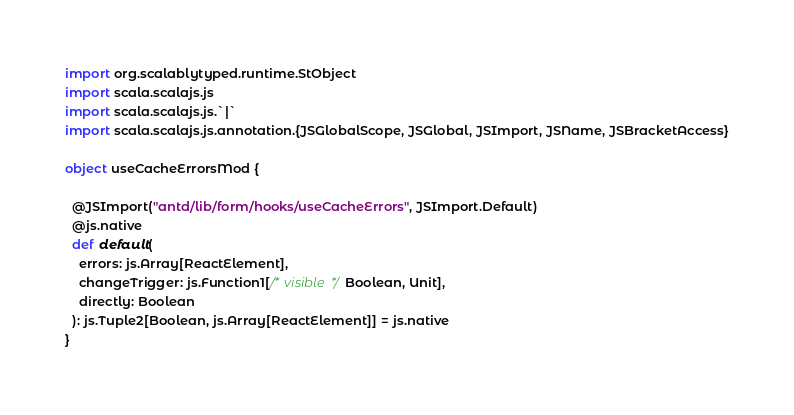<code> <loc_0><loc_0><loc_500><loc_500><_Scala_>import org.scalablytyped.runtime.StObject
import scala.scalajs.js
import scala.scalajs.js.`|`
import scala.scalajs.js.annotation.{JSGlobalScope, JSGlobal, JSImport, JSName, JSBracketAccess}

object useCacheErrorsMod {
  
  @JSImport("antd/lib/form/hooks/useCacheErrors", JSImport.Default)
  @js.native
  def default(
    errors: js.Array[ReactElement],
    changeTrigger: js.Function1[/* visible */ Boolean, Unit],
    directly: Boolean
  ): js.Tuple2[Boolean, js.Array[ReactElement]] = js.native
}
</code> 